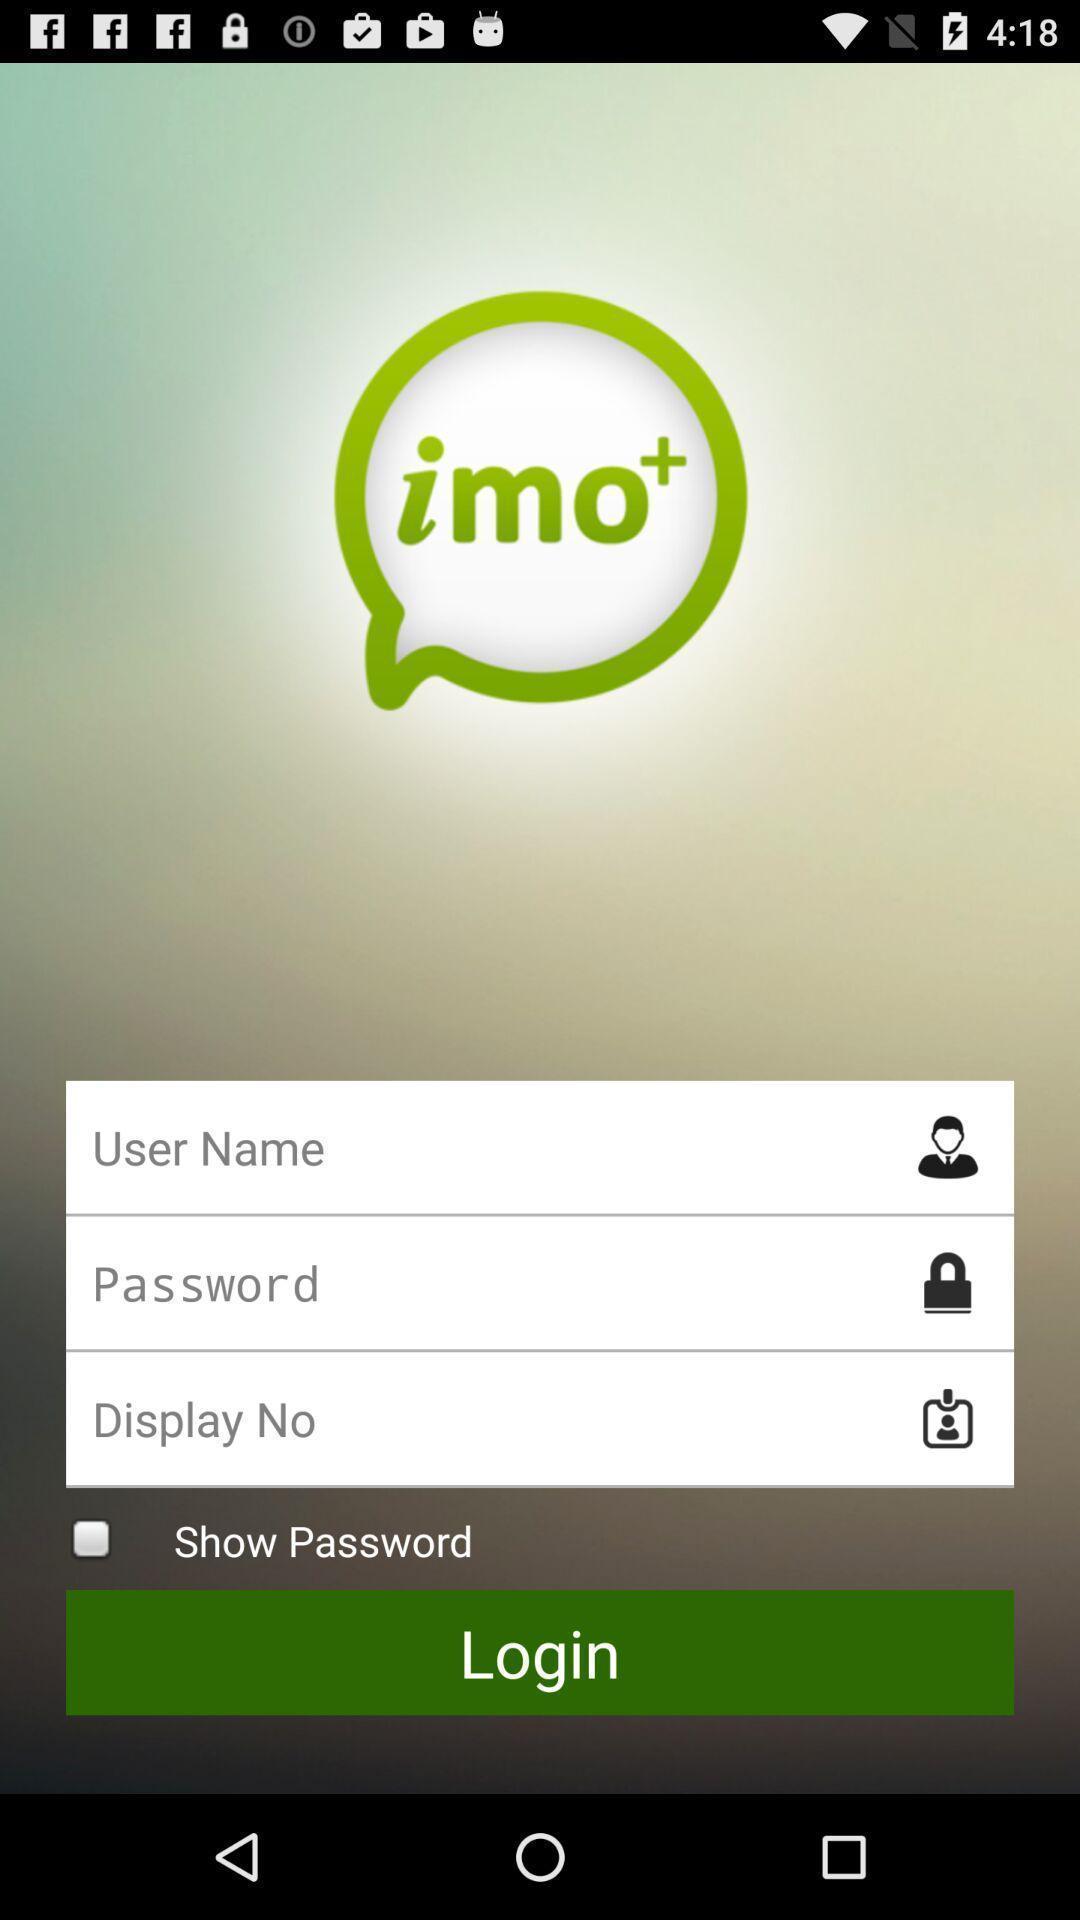What details can you identify in this image? Login page of the online meeting application. 